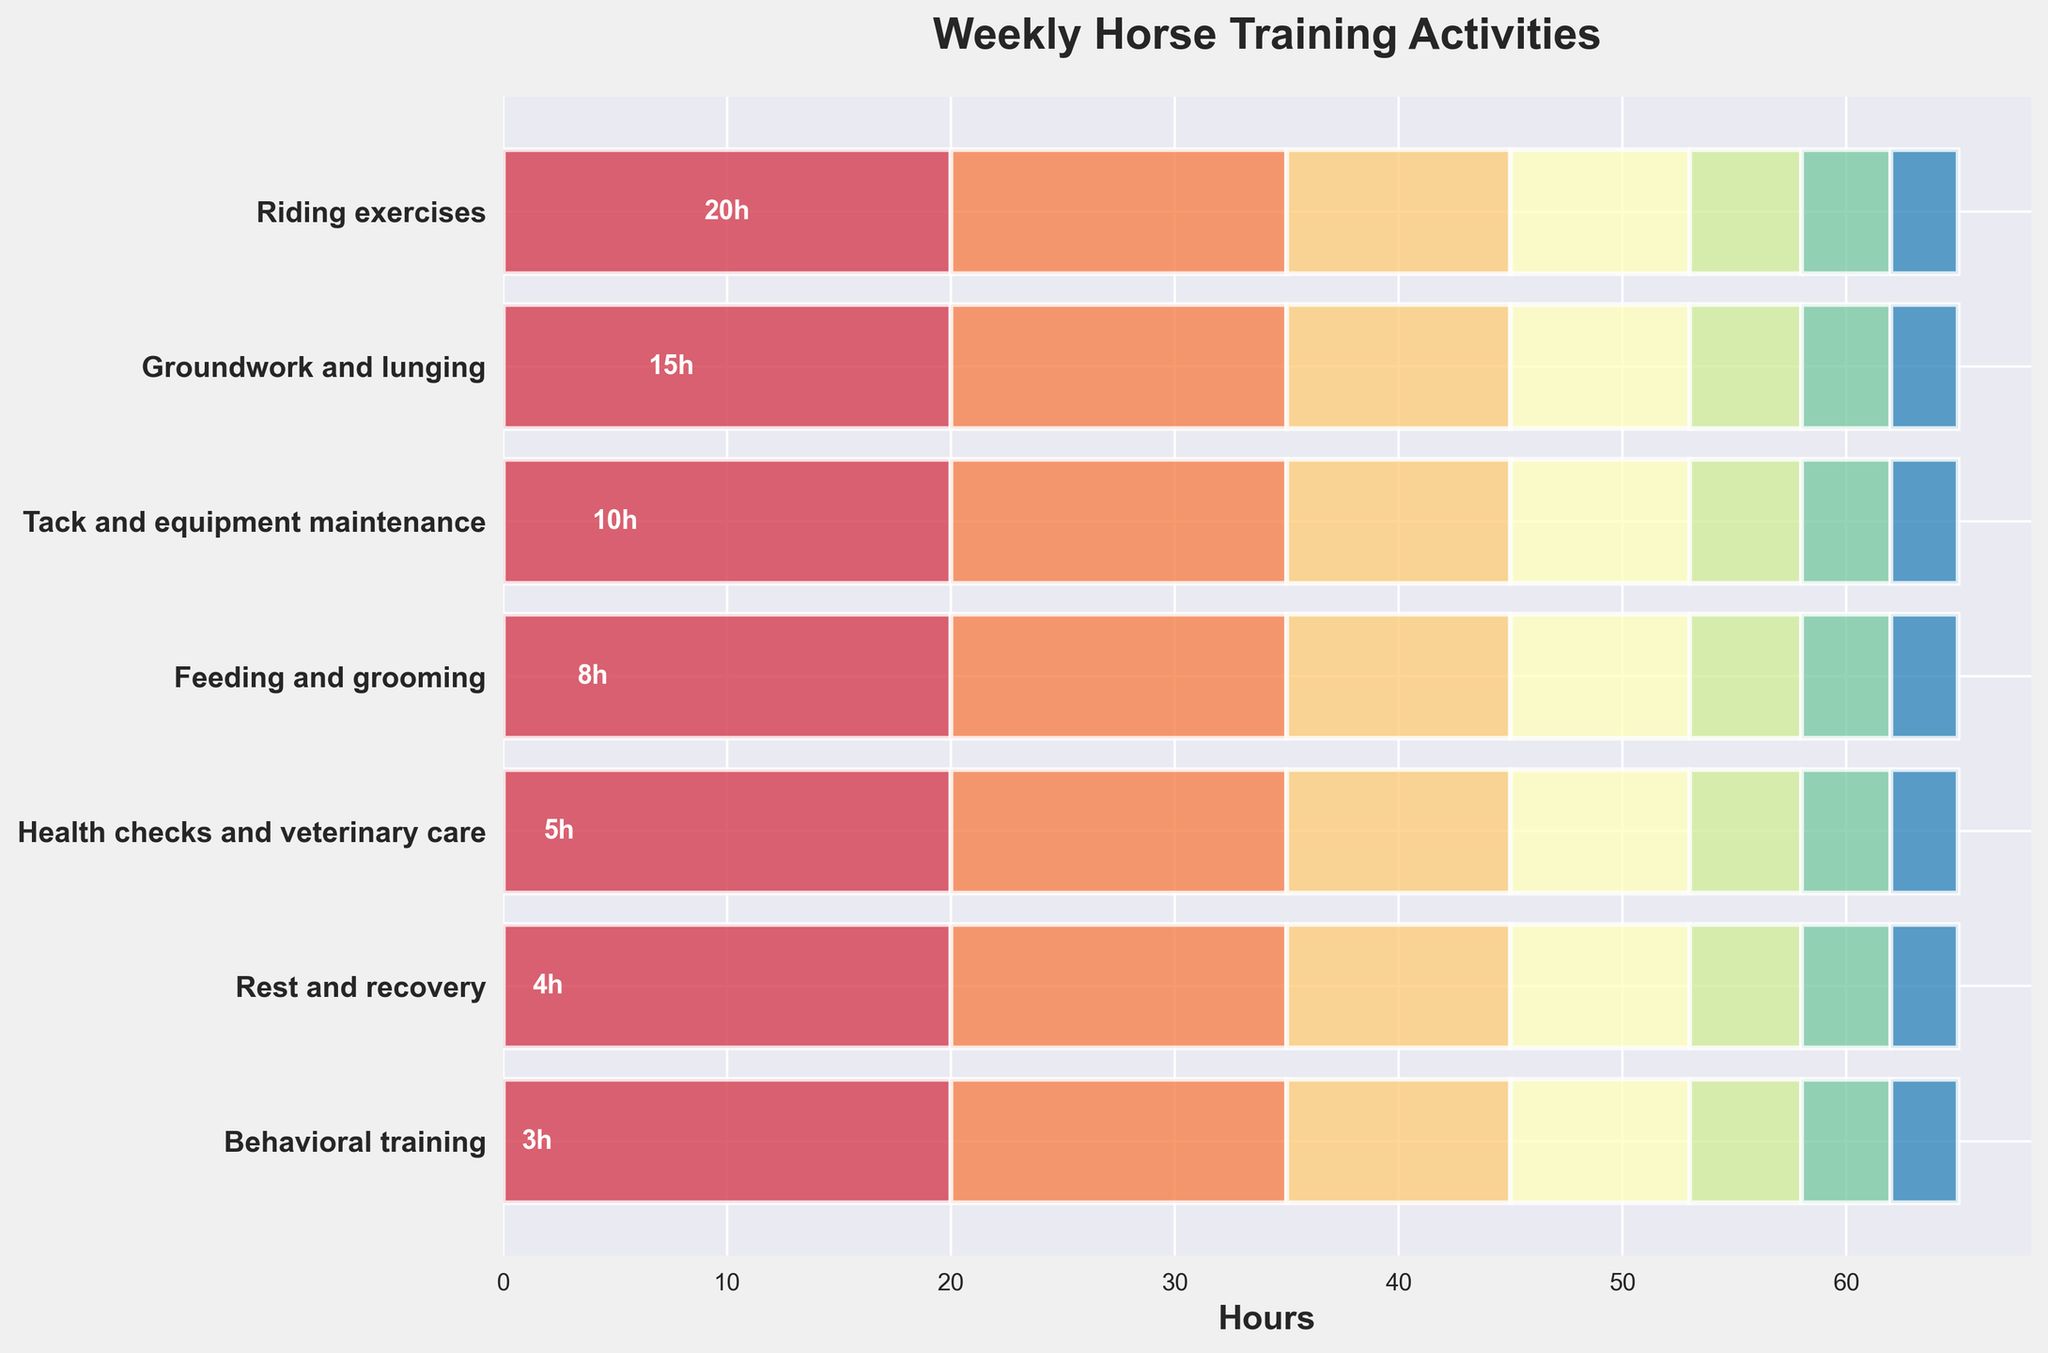What's the title of the figure? The title of a chart is usually displayed at the top. In this case, it's written in bold and reads 'Weekly Horse Training Activities'.
Answer: Weekly Horse Training Activities How many activities are displayed in the chart? Each bar in the chart represents an activity. By counting the bars, we see that there are 7 activities in total.
Answer: 7 Which activity takes up the most hours in the week? The horizontal bar with the longest length represents the activity with the most hours. The longest bar corresponds to 'Riding exercises' with 20 hours.
Answer: Riding exercises How much time is spent on 'Health checks and veterinary care'? In the chart, the bar corresponding to 'Health checks and veterinary care' has a label that shows 5 hours.
Answer: 5 hours What is the total time spent on 'Feeding and grooming' and 'Behavioral training'? From the chart, 'Feeding and grooming' is 8 hours and 'Behavioral training' is 3 hours. Adding these together: 8 + 3 = 11 hours.
Answer: 11 hours How many hours are dedicated to tack and equipment maintenance compared to groundwork and lunging? 'Tack and equipment maintenance' takes 10 hours, while 'Groundwork and lunging' takes 15 hours, as per the chart. The difference between them is 15 - 10 = 5.
Answer: 5 hours If 6 additional hours are added to 'Rest and recovery', how does it compare to 'Feeding and grooming'? 'Rest and recovery' currently takes 4 hours. Adding 6 hours to it gives 4 + 6 = 10 hours. 'Feeding and grooming' takes 8 hours. So, 10 - 8 = 2 hours more for 'Rest and recovery'.
Answer: 2 hours more What percentage of the total hours is spent on 'Groundwork and lunging'? First, calculate the total hours: 20 + 15 + 10 + 8 + 5 + 4 + 3 = 65 hours. 'Groundwork and lunging' is 15 hours. The percentage is (15 / 65) * 100 ≈ 23.08%.
Answer: 23.08% Given the sequence of activities, which one follows 'Tack and equipment maintenance'? The chart shows the activities in sequence from top to bottom. 'Tack and equipment maintenance' is followed by 'Feeding and grooming'.
Answer: Feeding and grooming If 'Behavioral training' is doubled in hours, what would be the new total weekly hours? 'Behavioral training' currently takes 3 hours. Doubling it gives 3 * 2 = 6 hours. Adding the difference (6 - 3 = 3) to the total hours (65) gives 65 + 3 = 68 hours.
Answer: 68 hours 